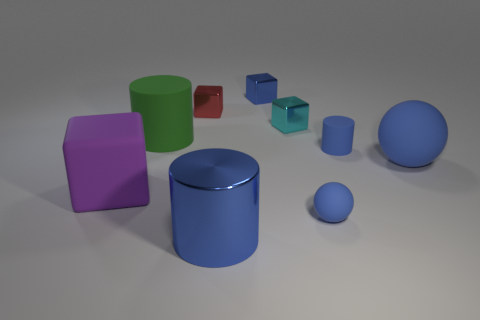Is there a matte object of the same color as the large matte ball?
Make the answer very short. Yes. Does the blue thing that is on the left side of the blue block have the same size as the blue cube?
Offer a very short reply. No. Is the number of big blue metal cylinders to the left of the green cylinder the same as the number of tiny purple objects?
Ensure brevity in your answer.  Yes. How many objects are either big purple matte objects that are in front of the tiny cyan metallic object or big cyan spheres?
Provide a succinct answer. 1. There is a thing that is both in front of the small cyan metallic thing and behind the blue rubber cylinder; what shape is it?
Keep it short and to the point. Cylinder. How many things are blue cylinders on the left side of the tiny blue matte cylinder or blue things to the right of the shiny cylinder?
Ensure brevity in your answer.  5. How many other things are the same size as the red metallic thing?
Your answer should be very brief. 4. There is a big cylinder right of the big green object; is it the same color as the tiny rubber sphere?
Offer a very short reply. Yes. There is a thing that is both on the left side of the tiny red thing and in front of the large blue ball; how big is it?
Make the answer very short. Large. How many small objects are cubes or purple rubber cubes?
Your response must be concise. 3. 